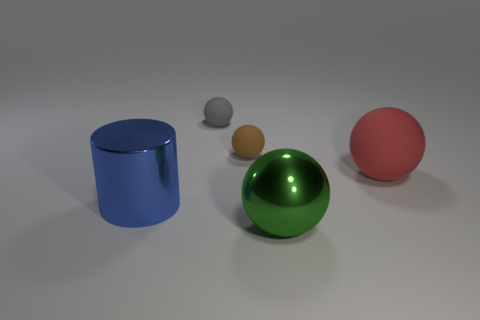Add 4 small gray things. How many objects exist? 9 Subtract all matte balls. How many balls are left? 1 Subtract 2 spheres. How many spheres are left? 2 Add 4 big yellow metal cubes. How many big yellow metal cubes exist? 4 Subtract all green balls. How many balls are left? 3 Subtract 0 yellow cylinders. How many objects are left? 5 Subtract all spheres. How many objects are left? 1 Subtract all blue spheres. Subtract all blue cylinders. How many spheres are left? 4 Subtract all gray cylinders. How many gray balls are left? 1 Subtract all large green things. Subtract all big rubber spheres. How many objects are left? 3 